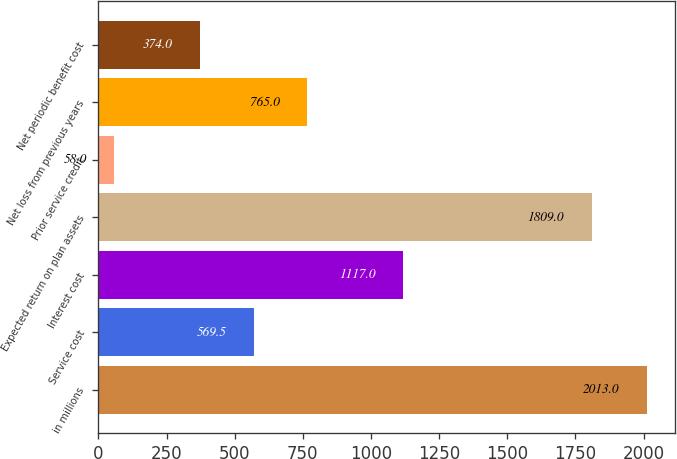<chart> <loc_0><loc_0><loc_500><loc_500><bar_chart><fcel>in millions<fcel>Service cost<fcel>Interest cost<fcel>Expected return on plan assets<fcel>Prior service credit<fcel>Net loss from previous years<fcel>Net periodic benefit cost<nl><fcel>2013<fcel>569.5<fcel>1117<fcel>1809<fcel>58<fcel>765<fcel>374<nl></chart> 